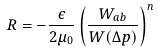Convert formula to latex. <formula><loc_0><loc_0><loc_500><loc_500>R = - \frac { \epsilon } { 2 \mu _ { 0 } } \left ( \frac { W _ { a b } } { W ( \Delta p ) } \right ) ^ { n }</formula> 